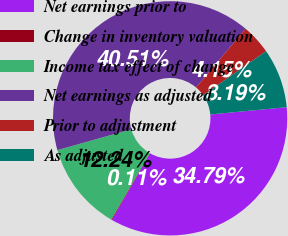Convert chart. <chart><loc_0><loc_0><loc_500><loc_500><pie_chart><fcel>Net earnings prior to<fcel>Change in inventory valuation<fcel>Income tax effect of change<fcel>Net earnings as adjusted<fcel>Prior to adjustment<fcel>As adjusted<nl><fcel>34.79%<fcel>0.11%<fcel>12.24%<fcel>40.51%<fcel>4.15%<fcel>8.19%<nl></chart> 